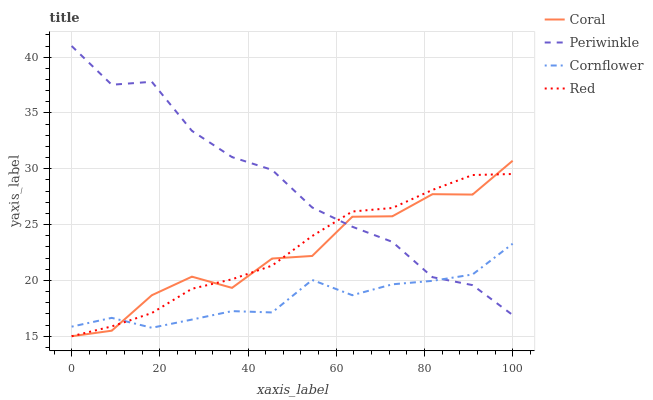Does Cornflower have the minimum area under the curve?
Answer yes or no. Yes. Does Periwinkle have the maximum area under the curve?
Answer yes or no. Yes. Does Coral have the minimum area under the curve?
Answer yes or no. No. Does Coral have the maximum area under the curve?
Answer yes or no. No. Is Red the smoothest?
Answer yes or no. Yes. Is Coral the roughest?
Answer yes or no. Yes. Is Periwinkle the smoothest?
Answer yes or no. No. Is Periwinkle the roughest?
Answer yes or no. No. Does Coral have the lowest value?
Answer yes or no. Yes. Does Periwinkle have the lowest value?
Answer yes or no. No. Does Periwinkle have the highest value?
Answer yes or no. Yes. Does Coral have the highest value?
Answer yes or no. No. Does Cornflower intersect Coral?
Answer yes or no. Yes. Is Cornflower less than Coral?
Answer yes or no. No. Is Cornflower greater than Coral?
Answer yes or no. No. 